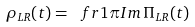Convert formula to latex. <formula><loc_0><loc_0><loc_500><loc_500>\rho _ { L R } ( t ) = \ f r { 1 } { \pi } { I m } \, \Pi _ { L R } ( t )</formula> 